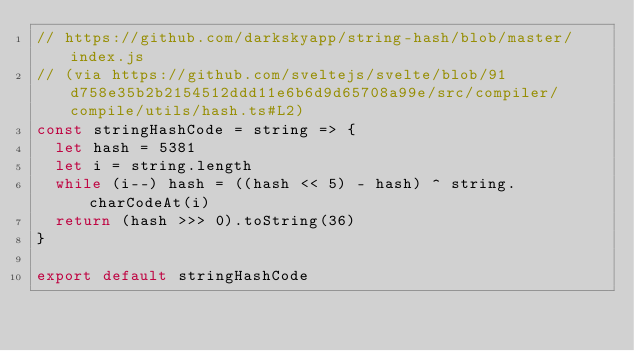<code> <loc_0><loc_0><loc_500><loc_500><_JavaScript_>// https://github.com/darkskyapp/string-hash/blob/master/index.js
// (via https://github.com/sveltejs/svelte/blob/91d758e35b2b2154512ddd11e6b6d9d65708a99e/src/compiler/compile/utils/hash.ts#L2)
const stringHashCode = string => {
  let hash = 5381
  let i = string.length
  while (i--) hash = ((hash << 5) - hash) ^ string.charCodeAt(i)
  return (hash >>> 0).toString(36)
}

export default stringHashCode
</code> 